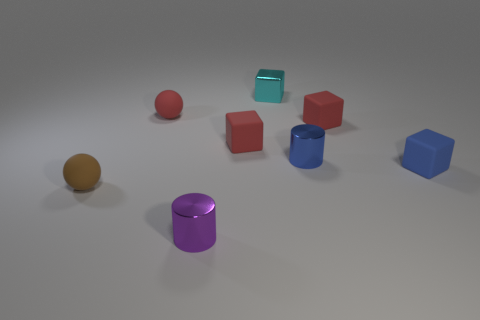How many things are small cyan metal objects or red things that are on the left side of the purple metallic object?
Your answer should be very brief. 2. There is a tiny cube that is in front of the metallic cylinder that is behind the blue matte object that is in front of the cyan shiny thing; what is its color?
Offer a terse response. Blue. How big is the matte sphere that is in front of the blue rubber cube?
Give a very brief answer. Small. What number of tiny things are cylinders or red rubber cubes?
Ensure brevity in your answer.  4. There is a shiny thing that is behind the brown object and in front of the small shiny block; what is its color?
Your answer should be very brief. Blue. Is there a small red object of the same shape as the brown object?
Keep it short and to the point. Yes. What is the material of the small brown object?
Give a very brief answer. Rubber. Are there any small red objects on the right side of the tiny cyan metal cube?
Offer a terse response. Yes. Do the blue metal thing and the purple shiny object have the same shape?
Provide a short and direct response. Yes. What number of other objects are there of the same size as the cyan metal object?
Offer a terse response. 7. 